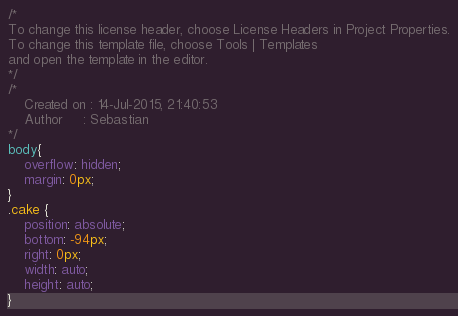Convert code to text. <code><loc_0><loc_0><loc_500><loc_500><_CSS_>/*
To change this license header, choose License Headers in Project Properties.
To change this template file, choose Tools | Templates
and open the template in the editor.
*/
/* 
    Created on : 14-Jul-2015, 21:40:53
    Author     : Sebastian
*/
body{
	overflow: hidden;
	margin: 0px;
}
.cake {
	position: absolute;
	bottom: -94px;
	right: 0px;
	width: auto;
	height: auto;
}</code> 